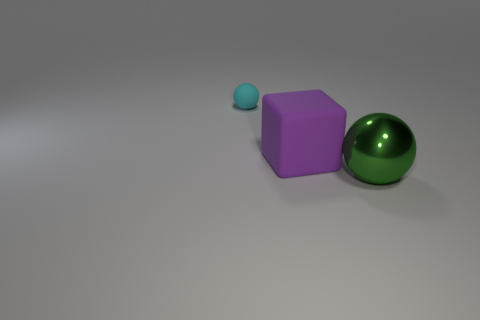Add 2 purple blocks. How many objects exist? 5 Subtract all cyan balls. How many balls are left? 1 Subtract 0 brown blocks. How many objects are left? 3 Subtract all cubes. How many objects are left? 2 Subtract 1 spheres. How many spheres are left? 1 Subtract all brown spheres. Subtract all yellow cylinders. How many spheres are left? 2 Subtract all red blocks. How many green spheres are left? 1 Subtract all purple matte cubes. Subtract all tiny objects. How many objects are left? 1 Add 3 big purple rubber blocks. How many big purple rubber blocks are left? 4 Add 1 tiny gray metal cylinders. How many tiny gray metal cylinders exist? 1 